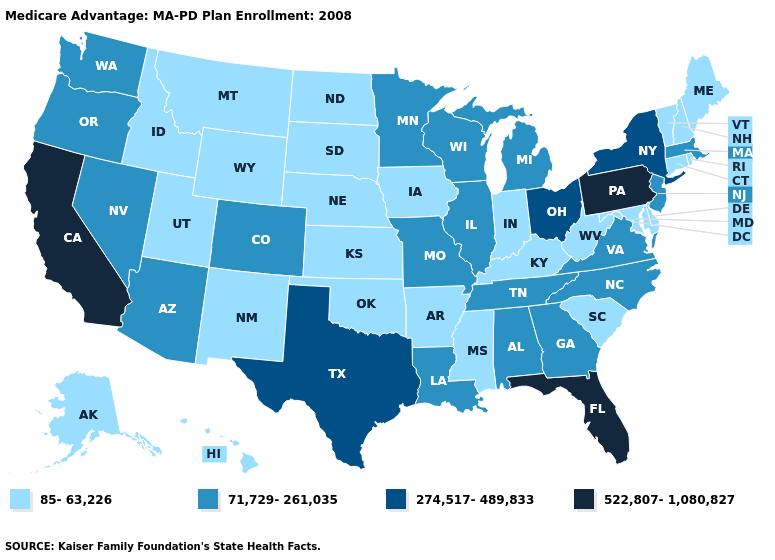Name the states that have a value in the range 71,729-261,035?
Keep it brief. Alabama, Arizona, Colorado, Georgia, Illinois, Louisiana, Massachusetts, Michigan, Minnesota, Missouri, North Carolina, New Jersey, Nevada, Oregon, Tennessee, Virginia, Washington, Wisconsin. Name the states that have a value in the range 71,729-261,035?
Short answer required. Alabama, Arizona, Colorado, Georgia, Illinois, Louisiana, Massachusetts, Michigan, Minnesota, Missouri, North Carolina, New Jersey, Nevada, Oregon, Tennessee, Virginia, Washington, Wisconsin. Does Florida have the highest value in the South?
Quick response, please. Yes. Among the states that border New Hampshire , does Maine have the lowest value?
Short answer required. Yes. Among the states that border Michigan , which have the highest value?
Answer briefly. Ohio. Which states hav the highest value in the South?
Be succinct. Florida. Which states hav the highest value in the MidWest?
Be succinct. Ohio. Does the first symbol in the legend represent the smallest category?
Short answer required. Yes. What is the value of Indiana?
Keep it brief. 85-63,226. What is the value of Alaska?
Answer briefly. 85-63,226. Name the states that have a value in the range 274,517-489,833?
Give a very brief answer. New York, Ohio, Texas. Does Tennessee have a higher value than Mississippi?
Write a very short answer. Yes. Does the map have missing data?
Keep it brief. No. Among the states that border Connecticut , which have the lowest value?
Give a very brief answer. Rhode Island. Does Illinois have a higher value than New Hampshire?
Write a very short answer. Yes. 